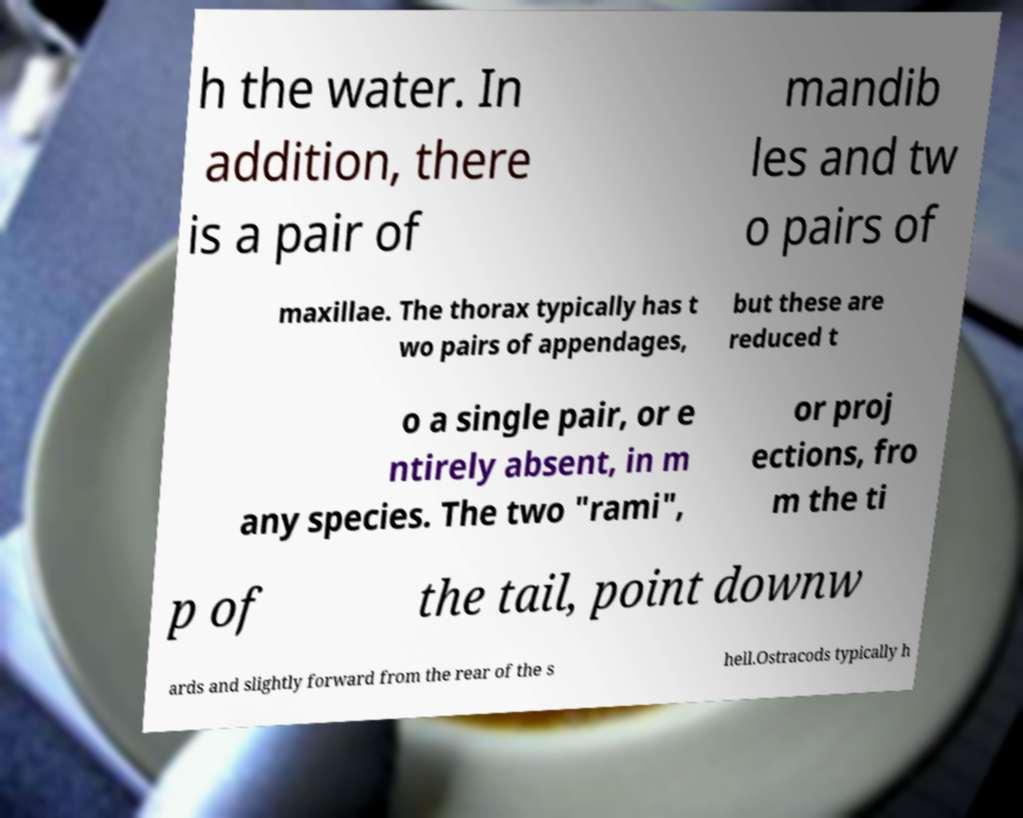Can you read and provide the text displayed in the image?This photo seems to have some interesting text. Can you extract and type it out for me? h the water. In addition, there is a pair of mandib les and tw o pairs of maxillae. The thorax typically has t wo pairs of appendages, but these are reduced t o a single pair, or e ntirely absent, in m any species. The two "rami", or proj ections, fro m the ti p of the tail, point downw ards and slightly forward from the rear of the s hell.Ostracods typically h 